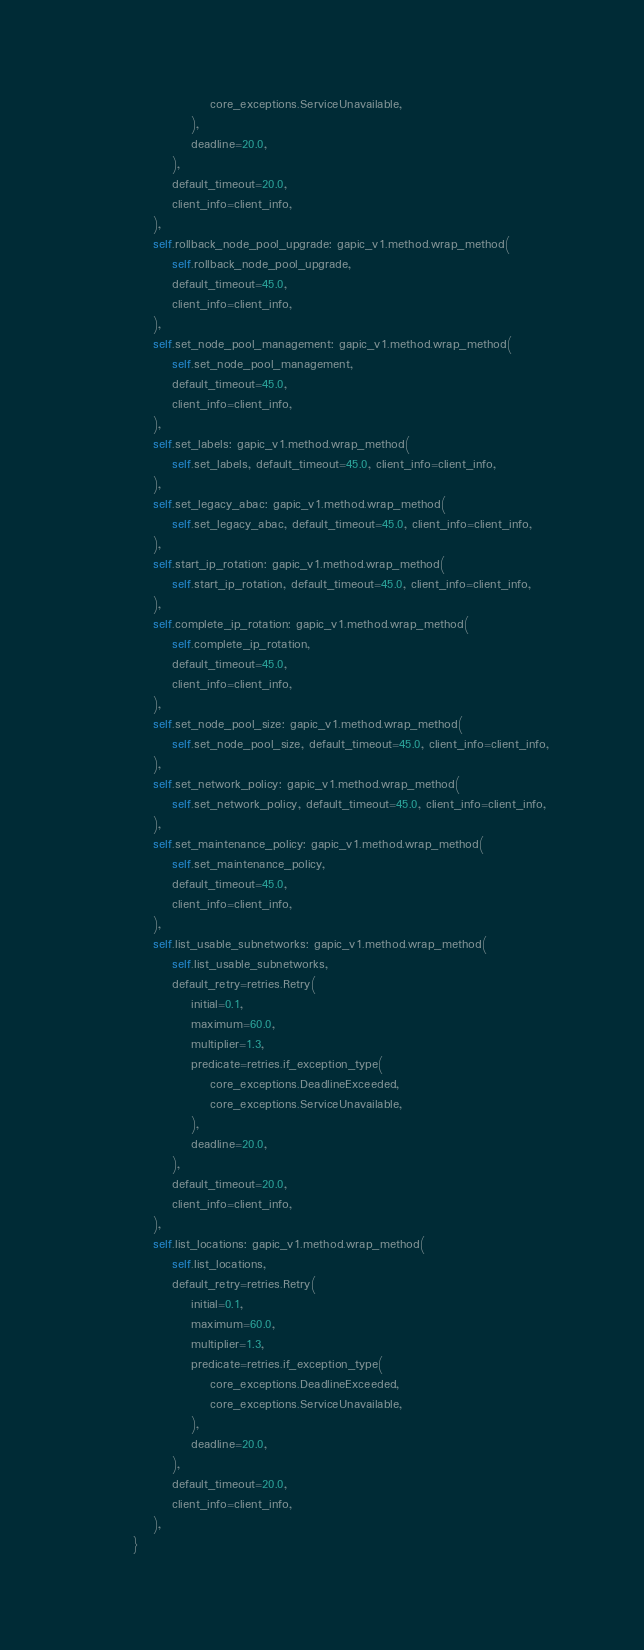<code> <loc_0><loc_0><loc_500><loc_500><_Python_>                        core_exceptions.ServiceUnavailable,
                    ),
                    deadline=20.0,
                ),
                default_timeout=20.0,
                client_info=client_info,
            ),
            self.rollback_node_pool_upgrade: gapic_v1.method.wrap_method(
                self.rollback_node_pool_upgrade,
                default_timeout=45.0,
                client_info=client_info,
            ),
            self.set_node_pool_management: gapic_v1.method.wrap_method(
                self.set_node_pool_management,
                default_timeout=45.0,
                client_info=client_info,
            ),
            self.set_labels: gapic_v1.method.wrap_method(
                self.set_labels, default_timeout=45.0, client_info=client_info,
            ),
            self.set_legacy_abac: gapic_v1.method.wrap_method(
                self.set_legacy_abac, default_timeout=45.0, client_info=client_info,
            ),
            self.start_ip_rotation: gapic_v1.method.wrap_method(
                self.start_ip_rotation, default_timeout=45.0, client_info=client_info,
            ),
            self.complete_ip_rotation: gapic_v1.method.wrap_method(
                self.complete_ip_rotation,
                default_timeout=45.0,
                client_info=client_info,
            ),
            self.set_node_pool_size: gapic_v1.method.wrap_method(
                self.set_node_pool_size, default_timeout=45.0, client_info=client_info,
            ),
            self.set_network_policy: gapic_v1.method.wrap_method(
                self.set_network_policy, default_timeout=45.0, client_info=client_info,
            ),
            self.set_maintenance_policy: gapic_v1.method.wrap_method(
                self.set_maintenance_policy,
                default_timeout=45.0,
                client_info=client_info,
            ),
            self.list_usable_subnetworks: gapic_v1.method.wrap_method(
                self.list_usable_subnetworks,
                default_retry=retries.Retry(
                    initial=0.1,
                    maximum=60.0,
                    multiplier=1.3,
                    predicate=retries.if_exception_type(
                        core_exceptions.DeadlineExceeded,
                        core_exceptions.ServiceUnavailable,
                    ),
                    deadline=20.0,
                ),
                default_timeout=20.0,
                client_info=client_info,
            ),
            self.list_locations: gapic_v1.method.wrap_method(
                self.list_locations,
                default_retry=retries.Retry(
                    initial=0.1,
                    maximum=60.0,
                    multiplier=1.3,
                    predicate=retries.if_exception_type(
                        core_exceptions.DeadlineExceeded,
                        core_exceptions.ServiceUnavailable,
                    ),
                    deadline=20.0,
                ),
                default_timeout=20.0,
                client_info=client_info,
            ),
        }
</code> 